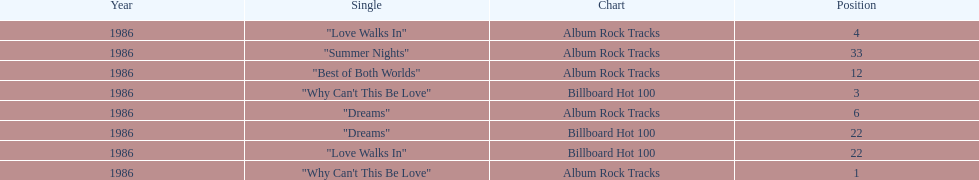Which singles each appear at position 22? Dreams, Love Walks In. 